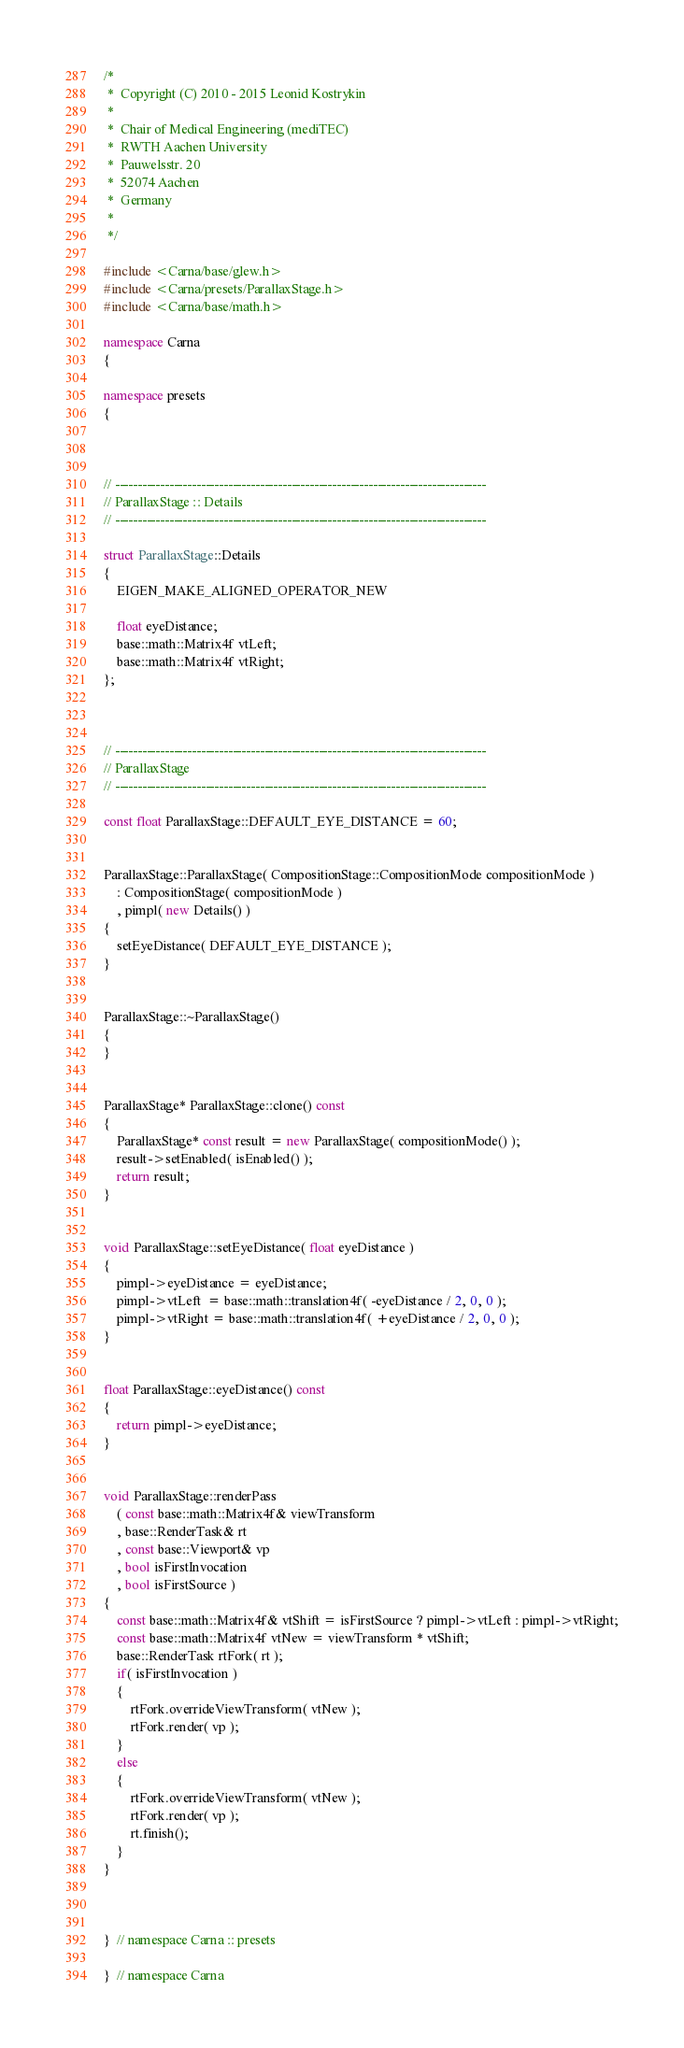Convert code to text. <code><loc_0><loc_0><loc_500><loc_500><_C++_>/*
 *  Copyright (C) 2010 - 2015 Leonid Kostrykin
 *
 *  Chair of Medical Engineering (mediTEC)
 *  RWTH Aachen University
 *  Pauwelsstr. 20
 *  52074 Aachen
 *  Germany
 *
 */

#include <Carna/base/glew.h>
#include <Carna/presets/ParallaxStage.h>
#include <Carna/base/math.h>

namespace Carna
{

namespace presets
{



// ----------------------------------------------------------------------------------
// ParallaxStage :: Details
// ----------------------------------------------------------------------------------

struct ParallaxStage::Details
{
    EIGEN_MAKE_ALIGNED_OPERATOR_NEW

    float eyeDistance;
    base::math::Matrix4f vtLeft;
    base::math::Matrix4f vtRight;
};



// ----------------------------------------------------------------------------------
// ParallaxStage
// ----------------------------------------------------------------------------------

const float ParallaxStage::DEFAULT_EYE_DISTANCE = 60;


ParallaxStage::ParallaxStage( CompositionStage::CompositionMode compositionMode )
    : CompositionStage( compositionMode )
    , pimpl( new Details() )
{
    setEyeDistance( DEFAULT_EYE_DISTANCE );
}


ParallaxStage::~ParallaxStage()
{
}


ParallaxStage* ParallaxStage::clone() const
{
    ParallaxStage* const result = new ParallaxStage( compositionMode() );
    result->setEnabled( isEnabled() );
    return result;
}


void ParallaxStage::setEyeDistance( float eyeDistance )
{
    pimpl->eyeDistance = eyeDistance;
    pimpl->vtLeft  = base::math::translation4f( -eyeDistance / 2, 0, 0 );
    pimpl->vtRight = base::math::translation4f( +eyeDistance / 2, 0, 0 );
}


float ParallaxStage::eyeDistance() const
{
    return pimpl->eyeDistance;
}


void ParallaxStage::renderPass
    ( const base::math::Matrix4f& viewTransform
    , base::RenderTask& rt
    , const base::Viewport& vp
    , bool isFirstInvocation
    , bool isFirstSource )
{
    const base::math::Matrix4f& vtShift = isFirstSource ? pimpl->vtLeft : pimpl->vtRight;
    const base::math::Matrix4f vtNew = viewTransform * vtShift;
    base::RenderTask rtFork( rt );
    if( isFirstInvocation )
    {
        rtFork.overrideViewTransform( vtNew );
        rtFork.render( vp );
    }
    else
    {
        rtFork.overrideViewTransform( vtNew );
        rtFork.render( vp );
        rt.finish();
    }
}



}  // namespace Carna :: presets

}  // namespace Carna
</code> 